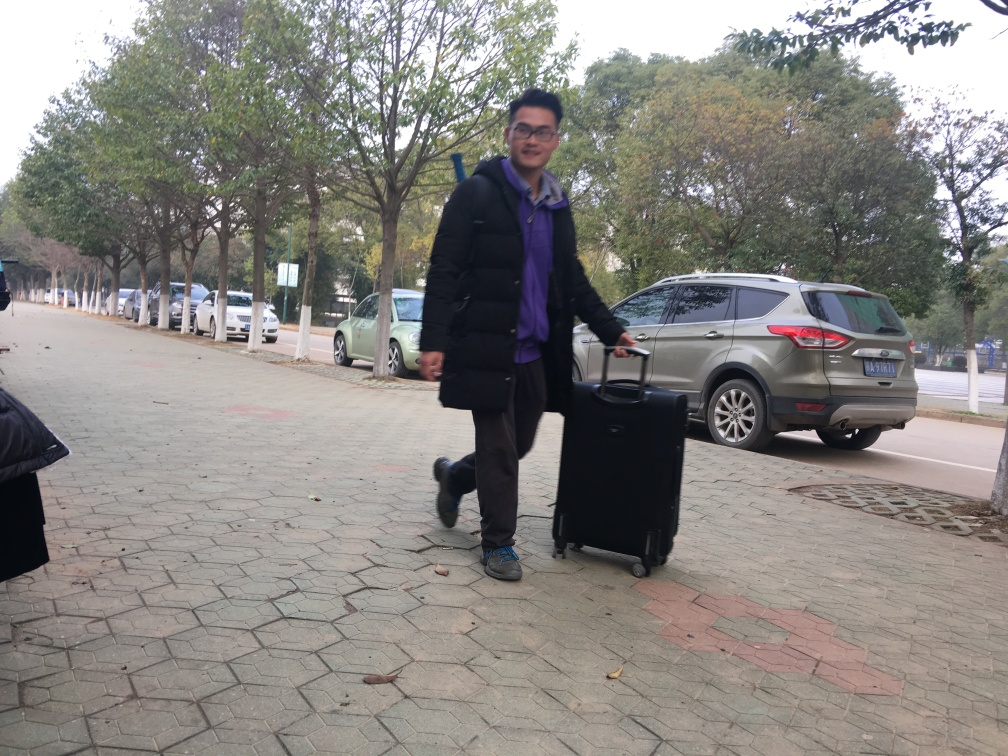What time of day does it appear to be and why? Based on the lighting and shadows present in the image, it appears to be daytime. The overcast sky suggests it might be late morning or early afternoon when the sun is obstructed by clouds, resulting in diffuse, soft light. What might this person be doing or where might he be going? Given that he's dressed warmly and is carrying luggage, it's likely the person is either arriving at or departing from a location. The brisk stride and attire suggest he could be commuting to a travel hub such as an airport or train station. 